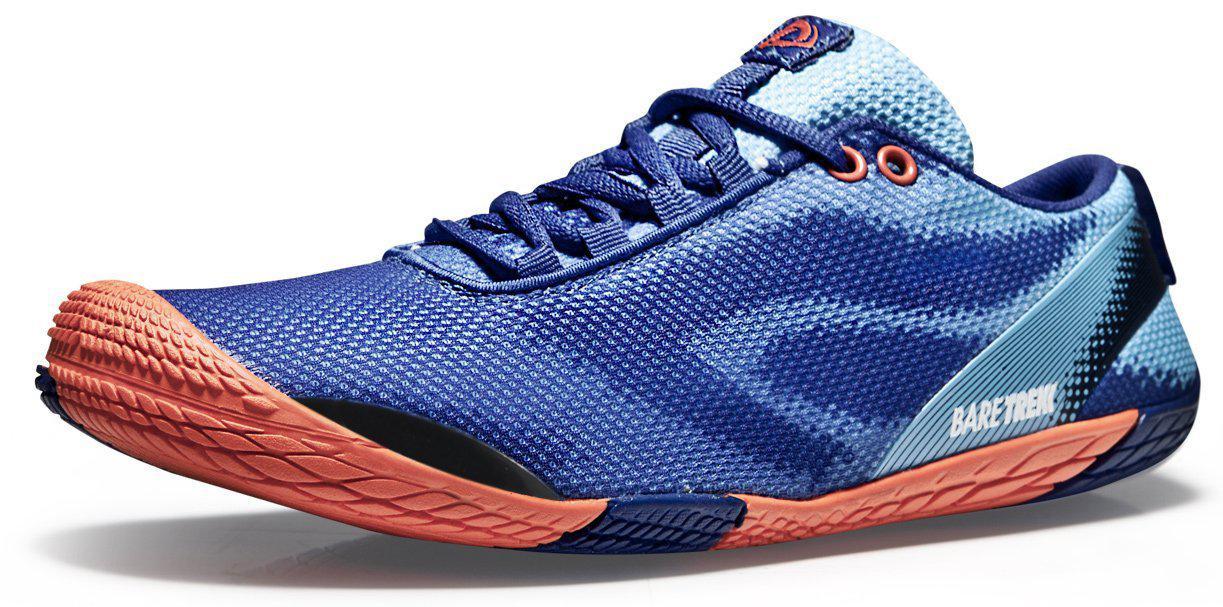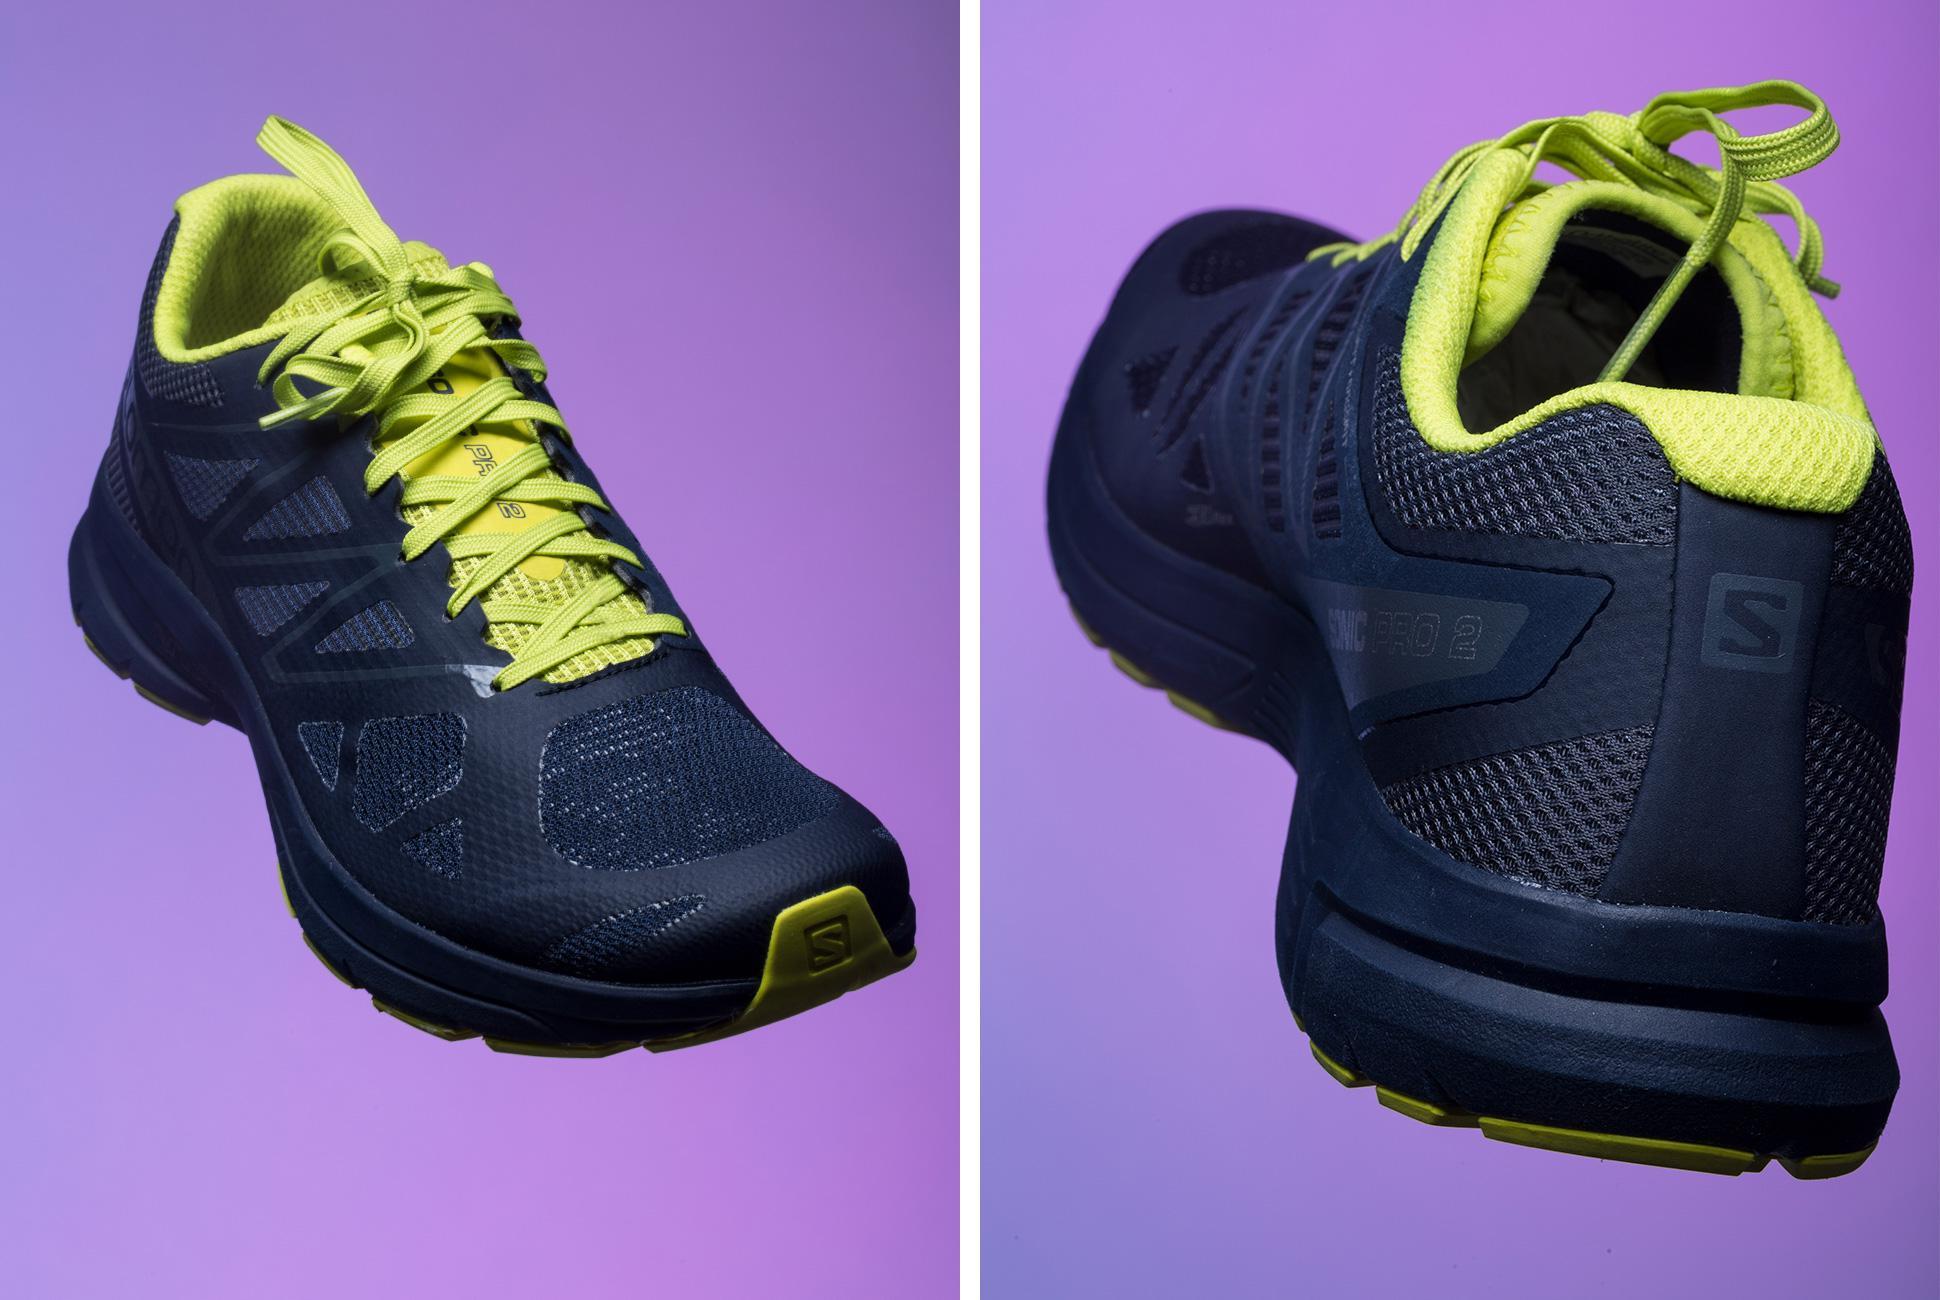The first image is the image on the left, the second image is the image on the right. Examine the images to the left and right. Is the description "There is a pair of matching shoes in at least one of the images." accurate? Answer yes or no. Yes. The first image is the image on the left, the second image is the image on the right. Evaluate the accuracy of this statement regarding the images: "No more than four sneakers are shown in total, and one sneaker is shown heel-first.". Is it true? Answer yes or no. Yes. 